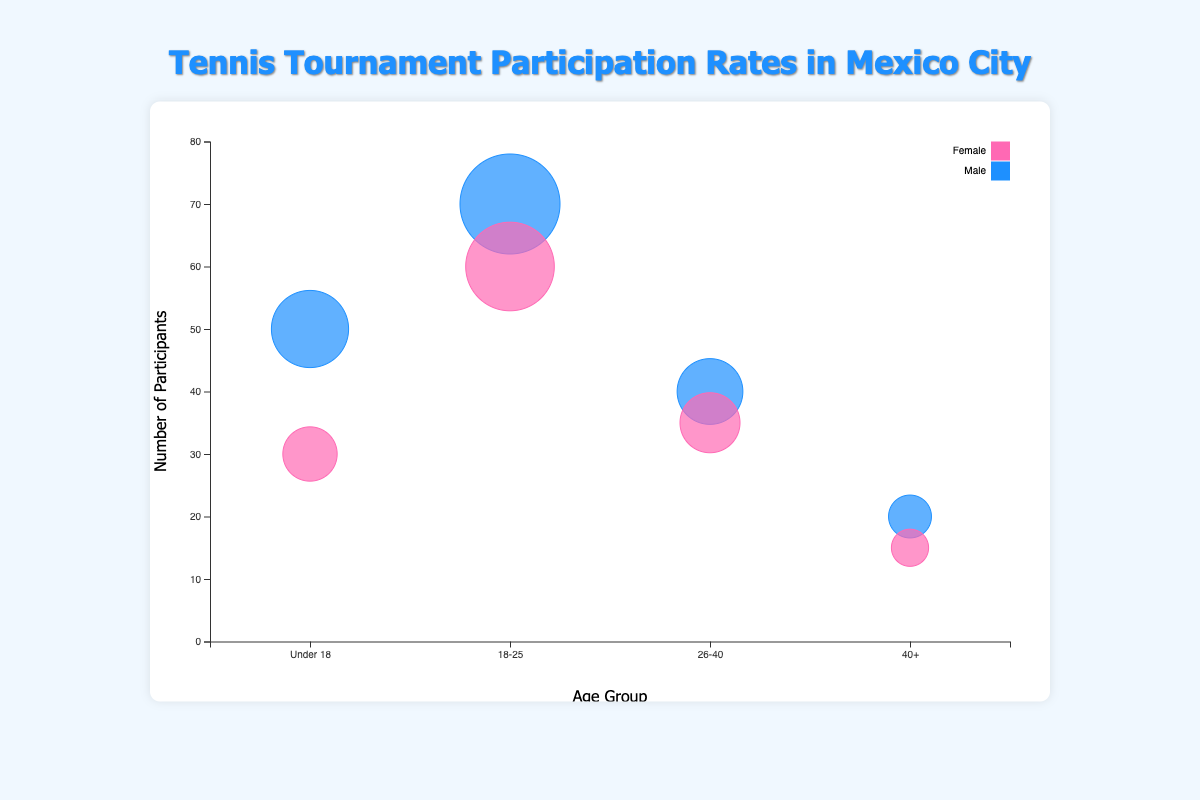What is the title of the figure? The title of the figure is displayed at the top of the chart. Reading it directly will give us this information.
Answer: "Tennis Tournament Participation Rates in Mexico City" How many age groups are displayed on the x-axis? By observing the x-axis, we can count the distinct points for different age groups.
Answer: 4 Which age group has the highest number of participants for males in the Mexico City Open? We need to look for the largest bubble representing males in the Mexico City Open and note its position on the x-axis.
Answer: 18-25 Between males and females in the 26-40 age group, who has more participants in the Mexico City Amateur Cup? We compare the sizes of the bubbles representing males and females in the 26-40 age group in the Mexico City Amateur Cup.
Answer: Males What's the difference in the number of participants between males and females in the Under 18 age group for the Mexico City Open? Subtract the number of female participants from the number of male participants in the Under 18 age group.
Answer: 20 What's the total number of participants in the 18-25 age group for both tournaments combined? Sum the participants from both the Mexico City Open and the Mexico City Amateur Cup for the 18-25 age group.
Answer: 250 Which age group has the smallest bubble for females in the Mexico City Amateur Cup? We examine the bubble sizes for females in the Mexico City Amateur Cup and identify the smallest one.
Answer: 40+ How many bubbles are there in total for each tournament? Count the total number of bubbles (data points) for each tournament.
Answer: 8 per tournament Which tournament has higher participation for the 40+ age group for both genders combined? Sum the participants for both genders in the 40+ age group for each tournament, then compare.
Answer: Mexico City Open Are the participation rates for males and females in the Under 18 age group closer in the Mexico City Open or the Mexico City Amateur Cup? Calculate the differences in participation rates for males and females in the Under 18 age group for both tournaments, then compare the differences.
Answer: Mexico City Amateur Cup 